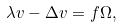<formula> <loc_0><loc_0><loc_500><loc_500>\lambda v - \Delta v = f \Omega ,</formula> 